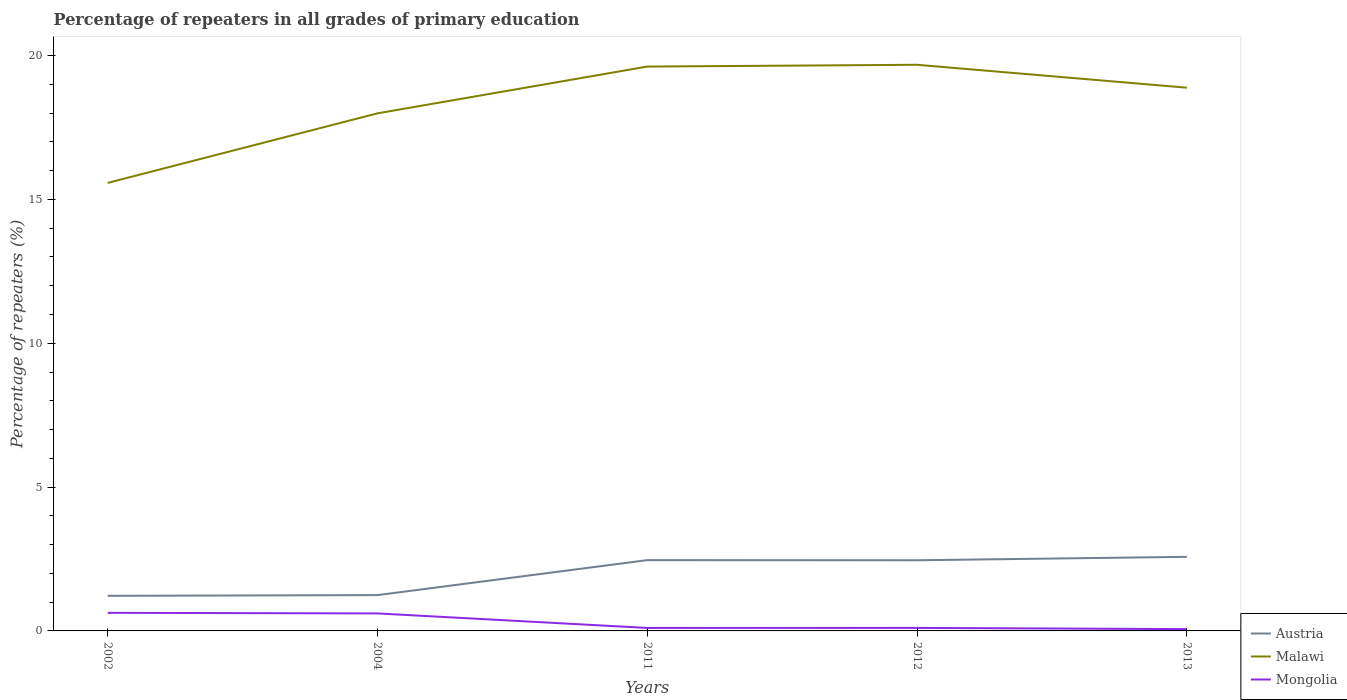How many different coloured lines are there?
Ensure brevity in your answer.  3. Across all years, what is the maximum percentage of repeaters in Mongolia?
Your answer should be very brief. 0.06. What is the total percentage of repeaters in Malawi in the graph?
Make the answer very short. -1.63. What is the difference between the highest and the second highest percentage of repeaters in Mongolia?
Offer a terse response. 0.57. What is the difference between the highest and the lowest percentage of repeaters in Mongolia?
Offer a very short reply. 2. Is the percentage of repeaters in Austria strictly greater than the percentage of repeaters in Malawi over the years?
Ensure brevity in your answer.  Yes. What is the difference between two consecutive major ticks on the Y-axis?
Offer a terse response. 5. Are the values on the major ticks of Y-axis written in scientific E-notation?
Provide a succinct answer. No. Does the graph contain any zero values?
Keep it short and to the point. No. How many legend labels are there?
Your response must be concise. 3. How are the legend labels stacked?
Your response must be concise. Vertical. What is the title of the graph?
Offer a terse response. Percentage of repeaters in all grades of primary education. What is the label or title of the X-axis?
Offer a very short reply. Years. What is the label or title of the Y-axis?
Give a very brief answer. Percentage of repeaters (%). What is the Percentage of repeaters (%) in Austria in 2002?
Your response must be concise. 1.22. What is the Percentage of repeaters (%) in Malawi in 2002?
Your answer should be very brief. 15.57. What is the Percentage of repeaters (%) in Mongolia in 2002?
Your response must be concise. 0.63. What is the Percentage of repeaters (%) of Austria in 2004?
Give a very brief answer. 1.24. What is the Percentage of repeaters (%) of Malawi in 2004?
Your response must be concise. 17.99. What is the Percentage of repeaters (%) of Mongolia in 2004?
Make the answer very short. 0.61. What is the Percentage of repeaters (%) in Austria in 2011?
Your answer should be very brief. 2.46. What is the Percentage of repeaters (%) of Malawi in 2011?
Your answer should be very brief. 19.62. What is the Percentage of repeaters (%) in Mongolia in 2011?
Your answer should be very brief. 0.1. What is the Percentage of repeaters (%) of Austria in 2012?
Keep it short and to the point. 2.46. What is the Percentage of repeaters (%) of Malawi in 2012?
Offer a very short reply. 19.68. What is the Percentage of repeaters (%) of Mongolia in 2012?
Make the answer very short. 0.1. What is the Percentage of repeaters (%) in Austria in 2013?
Your answer should be very brief. 2.57. What is the Percentage of repeaters (%) of Malawi in 2013?
Give a very brief answer. 18.88. What is the Percentage of repeaters (%) of Mongolia in 2013?
Keep it short and to the point. 0.06. Across all years, what is the maximum Percentage of repeaters (%) in Austria?
Make the answer very short. 2.57. Across all years, what is the maximum Percentage of repeaters (%) in Malawi?
Offer a terse response. 19.68. Across all years, what is the maximum Percentage of repeaters (%) of Mongolia?
Offer a terse response. 0.63. Across all years, what is the minimum Percentage of repeaters (%) of Austria?
Provide a succinct answer. 1.22. Across all years, what is the minimum Percentage of repeaters (%) in Malawi?
Your response must be concise. 15.57. Across all years, what is the minimum Percentage of repeaters (%) of Mongolia?
Offer a terse response. 0.06. What is the total Percentage of repeaters (%) in Austria in the graph?
Make the answer very short. 9.96. What is the total Percentage of repeaters (%) of Malawi in the graph?
Keep it short and to the point. 91.74. What is the total Percentage of repeaters (%) of Mongolia in the graph?
Give a very brief answer. 1.51. What is the difference between the Percentage of repeaters (%) in Austria in 2002 and that in 2004?
Provide a succinct answer. -0.02. What is the difference between the Percentage of repeaters (%) of Malawi in 2002 and that in 2004?
Ensure brevity in your answer.  -2.42. What is the difference between the Percentage of repeaters (%) in Mongolia in 2002 and that in 2004?
Your response must be concise. 0.02. What is the difference between the Percentage of repeaters (%) of Austria in 2002 and that in 2011?
Offer a very short reply. -1.24. What is the difference between the Percentage of repeaters (%) in Malawi in 2002 and that in 2011?
Offer a very short reply. -4.04. What is the difference between the Percentage of repeaters (%) of Mongolia in 2002 and that in 2011?
Provide a short and direct response. 0.53. What is the difference between the Percentage of repeaters (%) of Austria in 2002 and that in 2012?
Offer a terse response. -1.24. What is the difference between the Percentage of repeaters (%) in Malawi in 2002 and that in 2012?
Offer a terse response. -4.11. What is the difference between the Percentage of repeaters (%) of Mongolia in 2002 and that in 2012?
Make the answer very short. 0.52. What is the difference between the Percentage of repeaters (%) in Austria in 2002 and that in 2013?
Provide a succinct answer. -1.35. What is the difference between the Percentage of repeaters (%) in Malawi in 2002 and that in 2013?
Offer a very short reply. -3.31. What is the difference between the Percentage of repeaters (%) of Mongolia in 2002 and that in 2013?
Ensure brevity in your answer.  0.57. What is the difference between the Percentage of repeaters (%) of Austria in 2004 and that in 2011?
Provide a short and direct response. -1.22. What is the difference between the Percentage of repeaters (%) in Malawi in 2004 and that in 2011?
Ensure brevity in your answer.  -1.63. What is the difference between the Percentage of repeaters (%) of Mongolia in 2004 and that in 2011?
Your response must be concise. 0.5. What is the difference between the Percentage of repeaters (%) in Austria in 2004 and that in 2012?
Provide a short and direct response. -1.21. What is the difference between the Percentage of repeaters (%) in Malawi in 2004 and that in 2012?
Your response must be concise. -1.69. What is the difference between the Percentage of repeaters (%) of Mongolia in 2004 and that in 2012?
Provide a succinct answer. 0.5. What is the difference between the Percentage of repeaters (%) in Austria in 2004 and that in 2013?
Your response must be concise. -1.33. What is the difference between the Percentage of repeaters (%) of Malawi in 2004 and that in 2013?
Provide a short and direct response. -0.89. What is the difference between the Percentage of repeaters (%) in Mongolia in 2004 and that in 2013?
Provide a succinct answer. 0.55. What is the difference between the Percentage of repeaters (%) of Austria in 2011 and that in 2012?
Keep it short and to the point. 0. What is the difference between the Percentage of repeaters (%) in Malawi in 2011 and that in 2012?
Provide a short and direct response. -0.06. What is the difference between the Percentage of repeaters (%) of Mongolia in 2011 and that in 2012?
Ensure brevity in your answer.  -0. What is the difference between the Percentage of repeaters (%) in Austria in 2011 and that in 2013?
Your response must be concise. -0.11. What is the difference between the Percentage of repeaters (%) of Malawi in 2011 and that in 2013?
Your response must be concise. 0.73. What is the difference between the Percentage of repeaters (%) in Mongolia in 2011 and that in 2013?
Your answer should be very brief. 0.04. What is the difference between the Percentage of repeaters (%) of Austria in 2012 and that in 2013?
Provide a succinct answer. -0.12. What is the difference between the Percentage of repeaters (%) in Malawi in 2012 and that in 2013?
Offer a terse response. 0.8. What is the difference between the Percentage of repeaters (%) of Mongolia in 2012 and that in 2013?
Keep it short and to the point. 0.04. What is the difference between the Percentage of repeaters (%) in Austria in 2002 and the Percentage of repeaters (%) in Malawi in 2004?
Your answer should be compact. -16.77. What is the difference between the Percentage of repeaters (%) of Austria in 2002 and the Percentage of repeaters (%) of Mongolia in 2004?
Your answer should be very brief. 0.61. What is the difference between the Percentage of repeaters (%) of Malawi in 2002 and the Percentage of repeaters (%) of Mongolia in 2004?
Provide a short and direct response. 14.97. What is the difference between the Percentage of repeaters (%) of Austria in 2002 and the Percentage of repeaters (%) of Malawi in 2011?
Make the answer very short. -18.4. What is the difference between the Percentage of repeaters (%) of Austria in 2002 and the Percentage of repeaters (%) of Mongolia in 2011?
Give a very brief answer. 1.12. What is the difference between the Percentage of repeaters (%) of Malawi in 2002 and the Percentage of repeaters (%) of Mongolia in 2011?
Make the answer very short. 15.47. What is the difference between the Percentage of repeaters (%) of Austria in 2002 and the Percentage of repeaters (%) of Malawi in 2012?
Your answer should be very brief. -18.46. What is the difference between the Percentage of repeaters (%) of Austria in 2002 and the Percentage of repeaters (%) of Mongolia in 2012?
Offer a terse response. 1.12. What is the difference between the Percentage of repeaters (%) in Malawi in 2002 and the Percentage of repeaters (%) in Mongolia in 2012?
Your answer should be very brief. 15.47. What is the difference between the Percentage of repeaters (%) in Austria in 2002 and the Percentage of repeaters (%) in Malawi in 2013?
Make the answer very short. -17.66. What is the difference between the Percentage of repeaters (%) in Austria in 2002 and the Percentage of repeaters (%) in Mongolia in 2013?
Offer a very short reply. 1.16. What is the difference between the Percentage of repeaters (%) of Malawi in 2002 and the Percentage of repeaters (%) of Mongolia in 2013?
Provide a short and direct response. 15.51. What is the difference between the Percentage of repeaters (%) in Austria in 2004 and the Percentage of repeaters (%) in Malawi in 2011?
Ensure brevity in your answer.  -18.37. What is the difference between the Percentage of repeaters (%) in Austria in 2004 and the Percentage of repeaters (%) in Mongolia in 2011?
Provide a short and direct response. 1.14. What is the difference between the Percentage of repeaters (%) in Malawi in 2004 and the Percentage of repeaters (%) in Mongolia in 2011?
Your answer should be very brief. 17.89. What is the difference between the Percentage of repeaters (%) in Austria in 2004 and the Percentage of repeaters (%) in Malawi in 2012?
Your response must be concise. -18.43. What is the difference between the Percentage of repeaters (%) of Austria in 2004 and the Percentage of repeaters (%) of Mongolia in 2012?
Offer a terse response. 1.14. What is the difference between the Percentage of repeaters (%) in Malawi in 2004 and the Percentage of repeaters (%) in Mongolia in 2012?
Offer a terse response. 17.89. What is the difference between the Percentage of repeaters (%) of Austria in 2004 and the Percentage of repeaters (%) of Malawi in 2013?
Provide a succinct answer. -17.64. What is the difference between the Percentage of repeaters (%) of Austria in 2004 and the Percentage of repeaters (%) of Mongolia in 2013?
Ensure brevity in your answer.  1.18. What is the difference between the Percentage of repeaters (%) of Malawi in 2004 and the Percentage of repeaters (%) of Mongolia in 2013?
Offer a very short reply. 17.93. What is the difference between the Percentage of repeaters (%) of Austria in 2011 and the Percentage of repeaters (%) of Malawi in 2012?
Provide a short and direct response. -17.22. What is the difference between the Percentage of repeaters (%) in Austria in 2011 and the Percentage of repeaters (%) in Mongolia in 2012?
Offer a terse response. 2.36. What is the difference between the Percentage of repeaters (%) in Malawi in 2011 and the Percentage of repeaters (%) in Mongolia in 2012?
Make the answer very short. 19.51. What is the difference between the Percentage of repeaters (%) of Austria in 2011 and the Percentage of repeaters (%) of Malawi in 2013?
Offer a terse response. -16.42. What is the difference between the Percentage of repeaters (%) of Austria in 2011 and the Percentage of repeaters (%) of Mongolia in 2013?
Your response must be concise. 2.4. What is the difference between the Percentage of repeaters (%) in Malawi in 2011 and the Percentage of repeaters (%) in Mongolia in 2013?
Ensure brevity in your answer.  19.55. What is the difference between the Percentage of repeaters (%) in Austria in 2012 and the Percentage of repeaters (%) in Malawi in 2013?
Keep it short and to the point. -16.43. What is the difference between the Percentage of repeaters (%) of Austria in 2012 and the Percentage of repeaters (%) of Mongolia in 2013?
Provide a succinct answer. 2.39. What is the difference between the Percentage of repeaters (%) in Malawi in 2012 and the Percentage of repeaters (%) in Mongolia in 2013?
Offer a very short reply. 19.62. What is the average Percentage of repeaters (%) of Austria per year?
Offer a very short reply. 1.99. What is the average Percentage of repeaters (%) in Malawi per year?
Keep it short and to the point. 18.35. What is the average Percentage of repeaters (%) of Mongolia per year?
Keep it short and to the point. 0.3. In the year 2002, what is the difference between the Percentage of repeaters (%) of Austria and Percentage of repeaters (%) of Malawi?
Provide a short and direct response. -14.35. In the year 2002, what is the difference between the Percentage of repeaters (%) in Austria and Percentage of repeaters (%) in Mongolia?
Offer a terse response. 0.59. In the year 2002, what is the difference between the Percentage of repeaters (%) in Malawi and Percentage of repeaters (%) in Mongolia?
Give a very brief answer. 14.94. In the year 2004, what is the difference between the Percentage of repeaters (%) in Austria and Percentage of repeaters (%) in Malawi?
Your answer should be very brief. -16.75. In the year 2004, what is the difference between the Percentage of repeaters (%) in Austria and Percentage of repeaters (%) in Mongolia?
Make the answer very short. 0.64. In the year 2004, what is the difference between the Percentage of repeaters (%) of Malawi and Percentage of repeaters (%) of Mongolia?
Give a very brief answer. 17.38. In the year 2011, what is the difference between the Percentage of repeaters (%) of Austria and Percentage of repeaters (%) of Malawi?
Provide a succinct answer. -17.16. In the year 2011, what is the difference between the Percentage of repeaters (%) in Austria and Percentage of repeaters (%) in Mongolia?
Ensure brevity in your answer.  2.36. In the year 2011, what is the difference between the Percentage of repeaters (%) in Malawi and Percentage of repeaters (%) in Mongolia?
Provide a succinct answer. 19.51. In the year 2012, what is the difference between the Percentage of repeaters (%) in Austria and Percentage of repeaters (%) in Malawi?
Your response must be concise. -17.22. In the year 2012, what is the difference between the Percentage of repeaters (%) in Austria and Percentage of repeaters (%) in Mongolia?
Your answer should be very brief. 2.35. In the year 2012, what is the difference between the Percentage of repeaters (%) in Malawi and Percentage of repeaters (%) in Mongolia?
Your response must be concise. 19.57. In the year 2013, what is the difference between the Percentage of repeaters (%) in Austria and Percentage of repeaters (%) in Malawi?
Ensure brevity in your answer.  -16.31. In the year 2013, what is the difference between the Percentage of repeaters (%) in Austria and Percentage of repeaters (%) in Mongolia?
Your answer should be compact. 2.51. In the year 2013, what is the difference between the Percentage of repeaters (%) of Malawi and Percentage of repeaters (%) of Mongolia?
Provide a short and direct response. 18.82. What is the ratio of the Percentage of repeaters (%) in Austria in 2002 to that in 2004?
Give a very brief answer. 0.98. What is the ratio of the Percentage of repeaters (%) in Malawi in 2002 to that in 2004?
Your answer should be very brief. 0.87. What is the ratio of the Percentage of repeaters (%) of Mongolia in 2002 to that in 2004?
Ensure brevity in your answer.  1.03. What is the ratio of the Percentage of repeaters (%) in Austria in 2002 to that in 2011?
Your response must be concise. 0.5. What is the ratio of the Percentage of repeaters (%) of Malawi in 2002 to that in 2011?
Provide a short and direct response. 0.79. What is the ratio of the Percentage of repeaters (%) in Mongolia in 2002 to that in 2011?
Make the answer very short. 6.06. What is the ratio of the Percentage of repeaters (%) in Austria in 2002 to that in 2012?
Keep it short and to the point. 0.5. What is the ratio of the Percentage of repeaters (%) in Malawi in 2002 to that in 2012?
Your answer should be compact. 0.79. What is the ratio of the Percentage of repeaters (%) in Mongolia in 2002 to that in 2012?
Make the answer very short. 6. What is the ratio of the Percentage of repeaters (%) of Austria in 2002 to that in 2013?
Ensure brevity in your answer.  0.47. What is the ratio of the Percentage of repeaters (%) in Malawi in 2002 to that in 2013?
Give a very brief answer. 0.82. What is the ratio of the Percentage of repeaters (%) in Mongolia in 2002 to that in 2013?
Provide a short and direct response. 10.03. What is the ratio of the Percentage of repeaters (%) in Austria in 2004 to that in 2011?
Provide a short and direct response. 0.51. What is the ratio of the Percentage of repeaters (%) in Malawi in 2004 to that in 2011?
Your answer should be very brief. 0.92. What is the ratio of the Percentage of repeaters (%) in Mongolia in 2004 to that in 2011?
Offer a very short reply. 5.85. What is the ratio of the Percentage of repeaters (%) of Austria in 2004 to that in 2012?
Give a very brief answer. 0.51. What is the ratio of the Percentage of repeaters (%) in Malawi in 2004 to that in 2012?
Provide a succinct answer. 0.91. What is the ratio of the Percentage of repeaters (%) in Mongolia in 2004 to that in 2012?
Your response must be concise. 5.8. What is the ratio of the Percentage of repeaters (%) in Austria in 2004 to that in 2013?
Offer a terse response. 0.48. What is the ratio of the Percentage of repeaters (%) in Malawi in 2004 to that in 2013?
Your response must be concise. 0.95. What is the ratio of the Percentage of repeaters (%) in Mongolia in 2004 to that in 2013?
Keep it short and to the point. 9.69. What is the ratio of the Percentage of repeaters (%) in Malawi in 2011 to that in 2012?
Ensure brevity in your answer.  1. What is the ratio of the Percentage of repeaters (%) in Mongolia in 2011 to that in 2012?
Offer a very short reply. 0.99. What is the ratio of the Percentage of repeaters (%) of Austria in 2011 to that in 2013?
Provide a short and direct response. 0.96. What is the ratio of the Percentage of repeaters (%) of Malawi in 2011 to that in 2013?
Offer a terse response. 1.04. What is the ratio of the Percentage of repeaters (%) in Mongolia in 2011 to that in 2013?
Make the answer very short. 1.66. What is the ratio of the Percentage of repeaters (%) of Austria in 2012 to that in 2013?
Your answer should be very brief. 0.95. What is the ratio of the Percentage of repeaters (%) in Malawi in 2012 to that in 2013?
Provide a short and direct response. 1.04. What is the ratio of the Percentage of repeaters (%) of Mongolia in 2012 to that in 2013?
Your answer should be compact. 1.67. What is the difference between the highest and the second highest Percentage of repeaters (%) of Austria?
Provide a succinct answer. 0.11. What is the difference between the highest and the second highest Percentage of repeaters (%) of Malawi?
Give a very brief answer. 0.06. What is the difference between the highest and the second highest Percentage of repeaters (%) in Mongolia?
Your answer should be compact. 0.02. What is the difference between the highest and the lowest Percentage of repeaters (%) in Austria?
Your answer should be very brief. 1.35. What is the difference between the highest and the lowest Percentage of repeaters (%) of Malawi?
Your answer should be compact. 4.11. What is the difference between the highest and the lowest Percentage of repeaters (%) of Mongolia?
Keep it short and to the point. 0.57. 